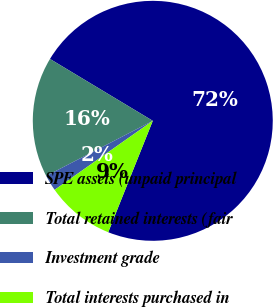<chart> <loc_0><loc_0><loc_500><loc_500><pie_chart><fcel>SPE assets (unpaid principal<fcel>Total retained interests (fair<fcel>Investment grade<fcel>Total interests purchased in<nl><fcel>72.44%<fcel>16.22%<fcel>2.16%<fcel>9.19%<nl></chart> 